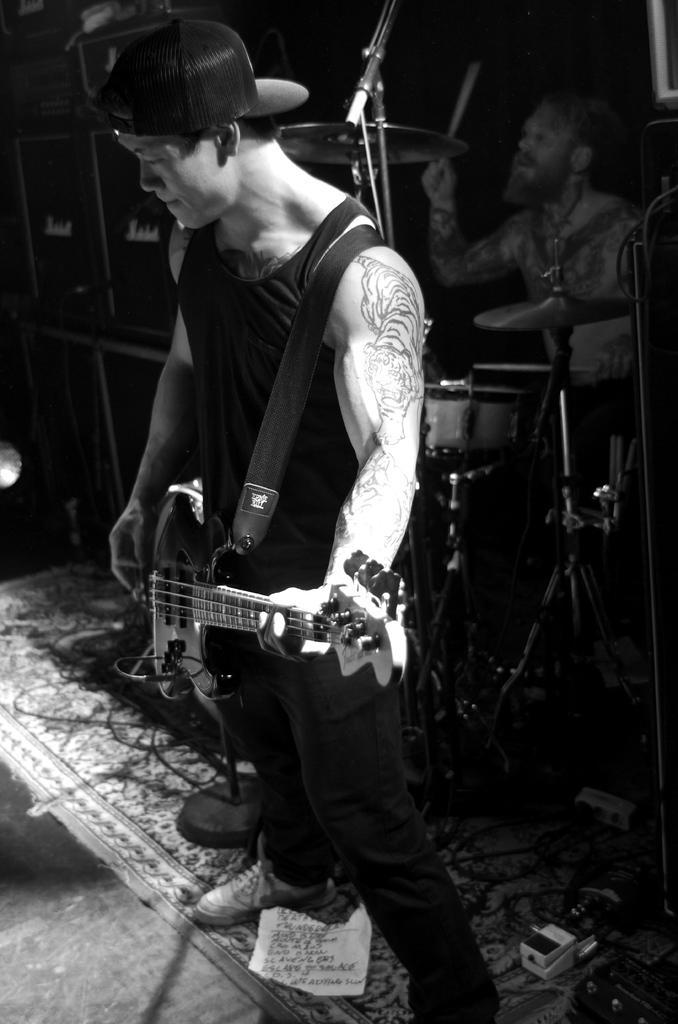In one or two sentences, can you explain what this image depicts? There is a person standing in the center. He is holding a guitar in his hand. In the background we can see a person playing a snare drum with drumsticks. 